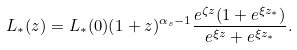Convert formula to latex. <formula><loc_0><loc_0><loc_500><loc_500>L _ { * } ( z ) = L _ { * } ( 0 ) ( 1 + z ) ^ { \alpha _ { s } - 1 } \frac { e ^ { \zeta z } ( 1 + e ^ { \xi z _ { * } } ) } { e ^ { \xi z } + e ^ { \xi z _ { * } } } .</formula> 